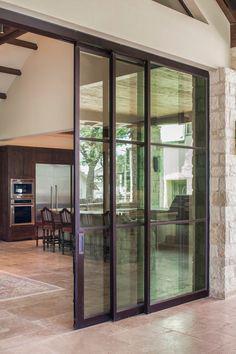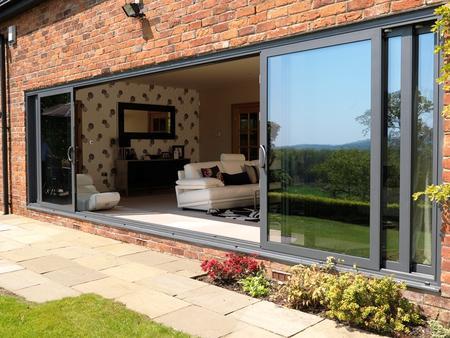The first image is the image on the left, the second image is the image on the right. Given the left and right images, does the statement "The right image is an exterior view of a white dark-framed sliding door unit, opened to show a furnished home interior." hold true? Answer yes or no. Yes. The first image is the image on the left, the second image is the image on the right. Given the left and right images, does the statement "there is a home with sliding glass doors open and looking into a living area from the outside" hold true? Answer yes or no. Yes. 